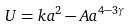Convert formula to latex. <formula><loc_0><loc_0><loc_500><loc_500>U = k a ^ { 2 } - A a ^ { 4 - 3 \gamma }</formula> 